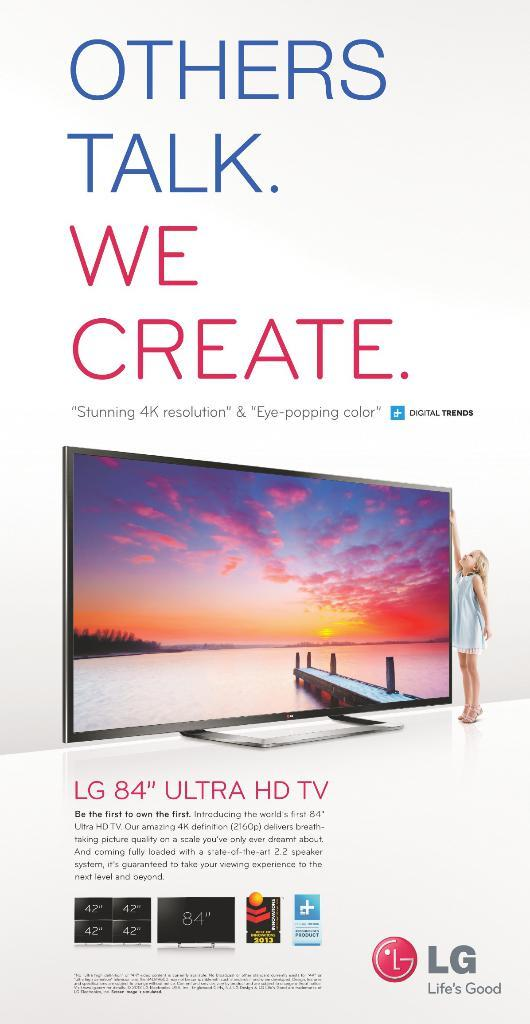What is the main subject of the image? The main subject of the image is an advertisement poster. What is depicted on the poster? There is a television in the poster. Are there any people in the poster? Yes, there is a girl standing on the side in the poster. What else can be found on the poster besides the image? There is text on the poster. How many beans are present in the image? There are no beans visible in the image; it features an advertisement poster with a television and a girl. 